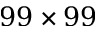<formula> <loc_0><loc_0><loc_500><loc_500>9 9 \times 9 9</formula> 